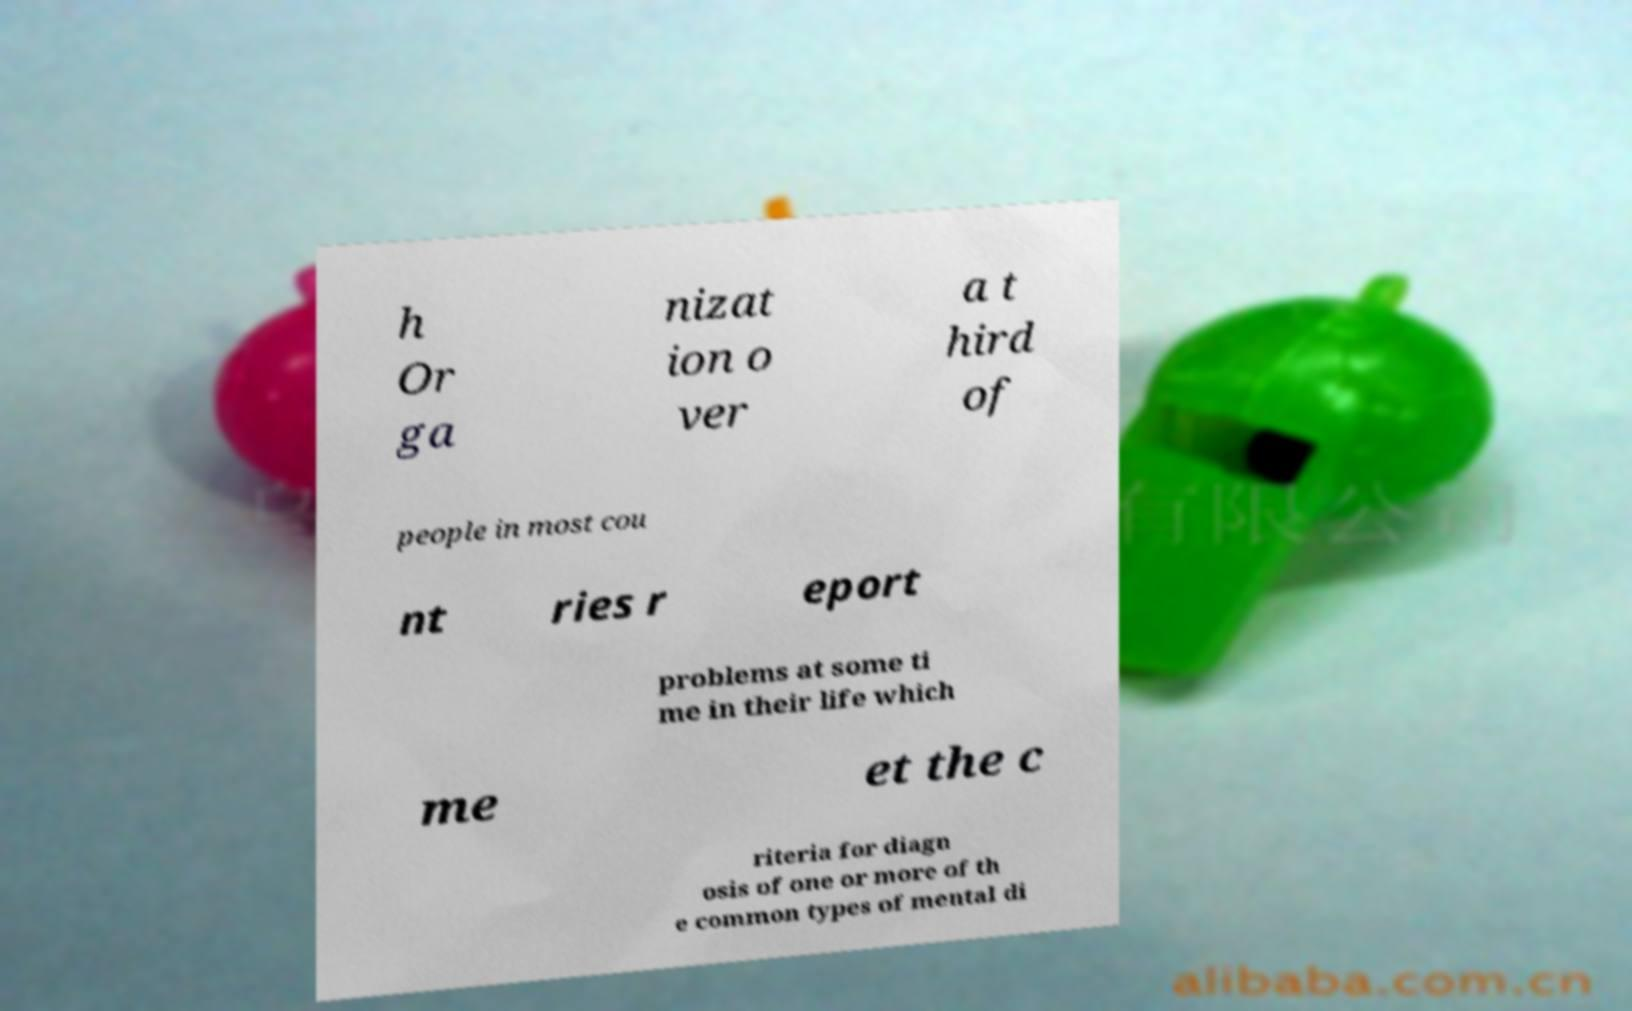There's text embedded in this image that I need extracted. Can you transcribe it verbatim? h Or ga nizat ion o ver a t hird of people in most cou nt ries r eport problems at some ti me in their life which me et the c riteria for diagn osis of one or more of th e common types of mental di 